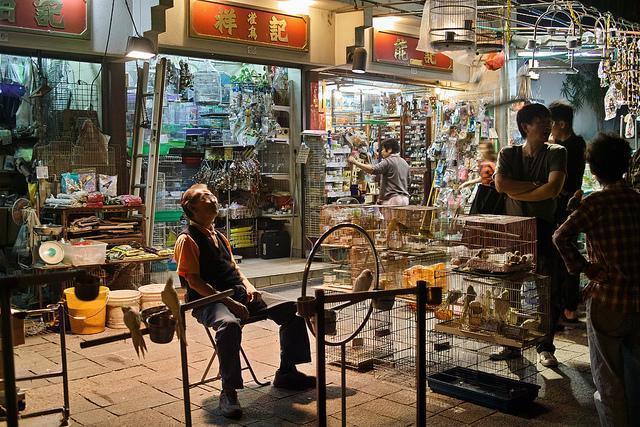The birds seen out of their cage here are sold for what purpose?
Answer the question by selecting the correct answer among the 4 following choices.
Options: Dinner, hat feathers, stealing jewels, pets. Pets. 